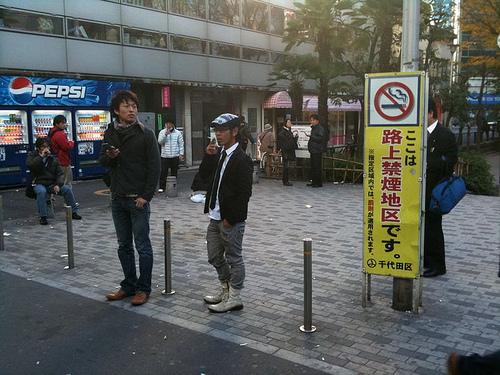Why is the pavement wet?
Be succinct. Rain. What language is present?
Write a very short answer. Chinese. What design is on the glass?
Keep it brief. Pepsi. Is this a third world country?
Write a very short answer. No. Is this a concession area, or is it a bus stop?
Give a very brief answer. Bus stop. What is the weather like?
Concise answer only. Cold. What language is on the ad?
Short answer required. Chinese. What color is his jacket?
Concise answer only. Black. How many people are on cell phones?
Give a very brief answer. 2. What is the man on the right hand side of the picture holding?
Concise answer only. Cigarette. How many people are sitting?
Write a very short answer. 1. How many people are outside?
Keep it brief. 10. What gender is the person wearing the pink coat?
Short answer required. Male. What soda's name is shown?
Keep it brief. Pepsi. 